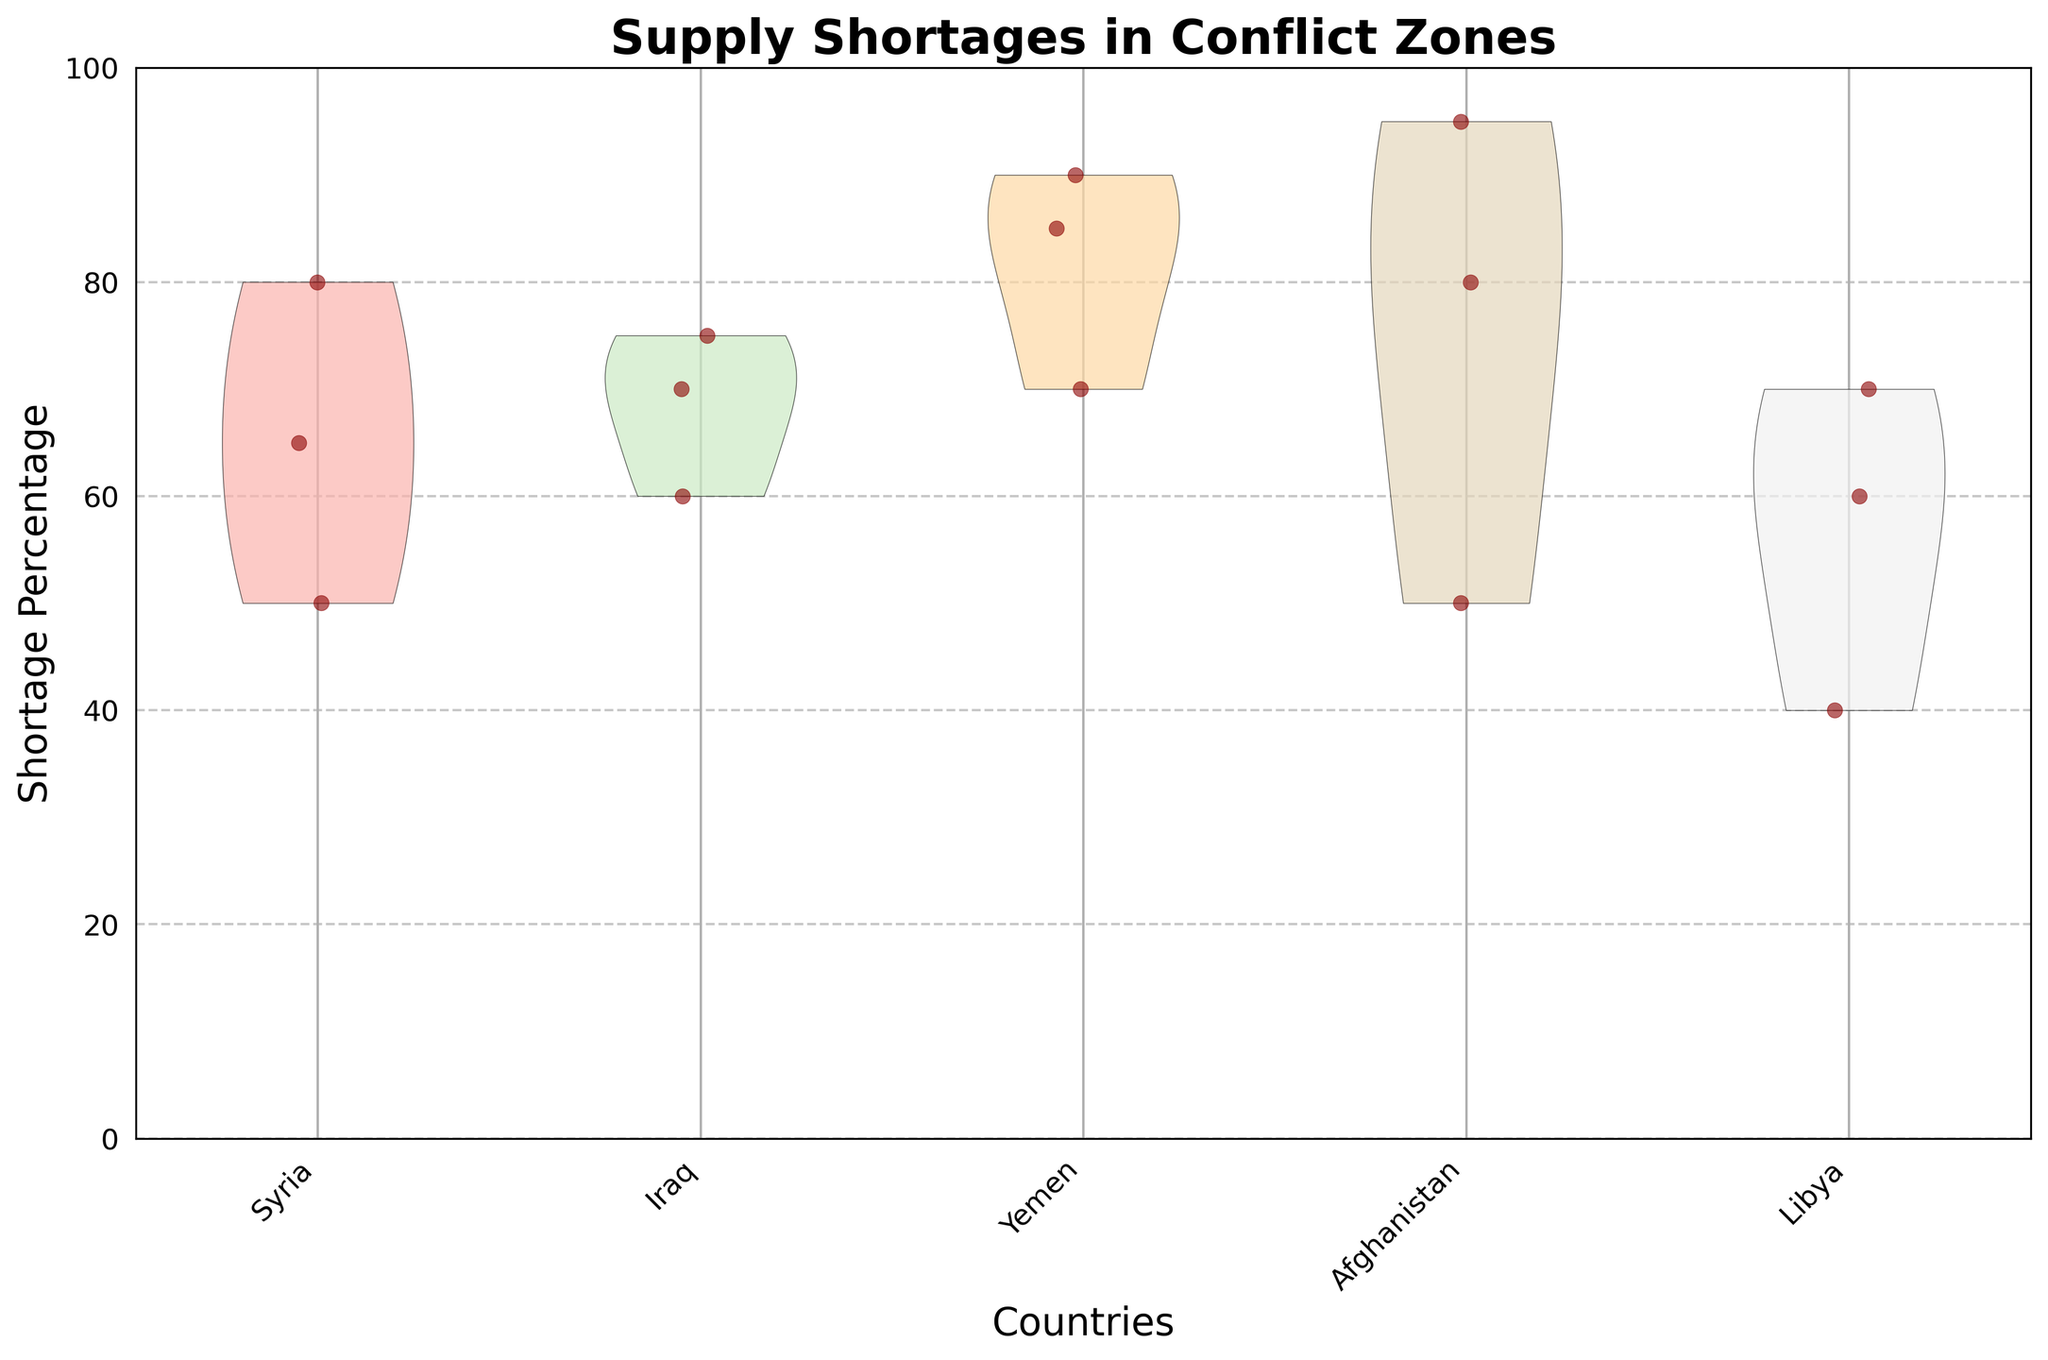What regions are included in the supply shortage data? The data shows shortages from five regions: Aleppo, Mosul, Sanaa, Kabul, and Tripoli, which are located in the countries Syria, Iraq, Yemen, Afghanistan, and Libya respectively. The violin chart labels represent these countries.
Answer: Aleppo, Mosul, Sanaa, Kabul, Tripoli What is the title of the figure? The title of the figure is displayed at the top of the chart. It reads "Supply Shortages in Conflict Zones."
Answer: Supply Shortages in Conflict Zones Which country shows the highest shortage percentage and what is it? Looking at the y-axis of the chart and the corresponding jittered points, the highest shortage percentage can be observed and compared across countries. Afghanistan shows the highest shortage with a percentage of 95.
Answer: Afghanistan, 95 Which country has the most consistent shortage percentages, and how can you tell? Consistency is indicated by the shape of the violin plot and the distribution of jittered points. Libya shows the most consistent shortages as its violin plot is narrower and its points are closely packed.
Answer: Libya What are the months where Sanaa experienced fuel shortages? Jittered points related to Sanaa can be checked for fuel shortages based on their distribution. Sanaa experienced fuel shortages in February.
Answer: February How does the median shortage in Mosul compare to the median shortage in Sanaa? To determine the median, observe the central tendency of the jittered points within the violin plots for Mosul and Sanaa. Mosul has a lower median shortage compared to Sanaa, as indicated by the positioning and distribution of the points.
Answer: Lower Comparatively, which country has the lowest percentage score in February? Observing the scatter points within each country's violin plot for February, one can identify the lowest value. Libya has the lowest percentage score in February with a shortage of 40.
Answer: Libya On average, which month had the highest shortage percentages across all regions? To find the average, observe the positioning of the jittered points for January, February, and March. Calculate the average visually by noting the central tendency of each month's distribution. January appears to have the highest average shortages.
Answer: January How are the colors used to distinguish between countries, and what are the colors used? Each country is represented with a distinct pastel color on the violin chart, aiding in differentiation. The colors are light and range from pastels like pinks, greens, light purple, etc.
Answer: Various pastel colors What is the spread of shortages in Kabul like, especially in comparison to Tripoli? The spread of shortages in a region is seen from the width and distribution in the violin plot. Kabul has a broader spread compared to Tripoli, indicating more variability in its shortages across months.
Answer: Kabul has a broader spread 